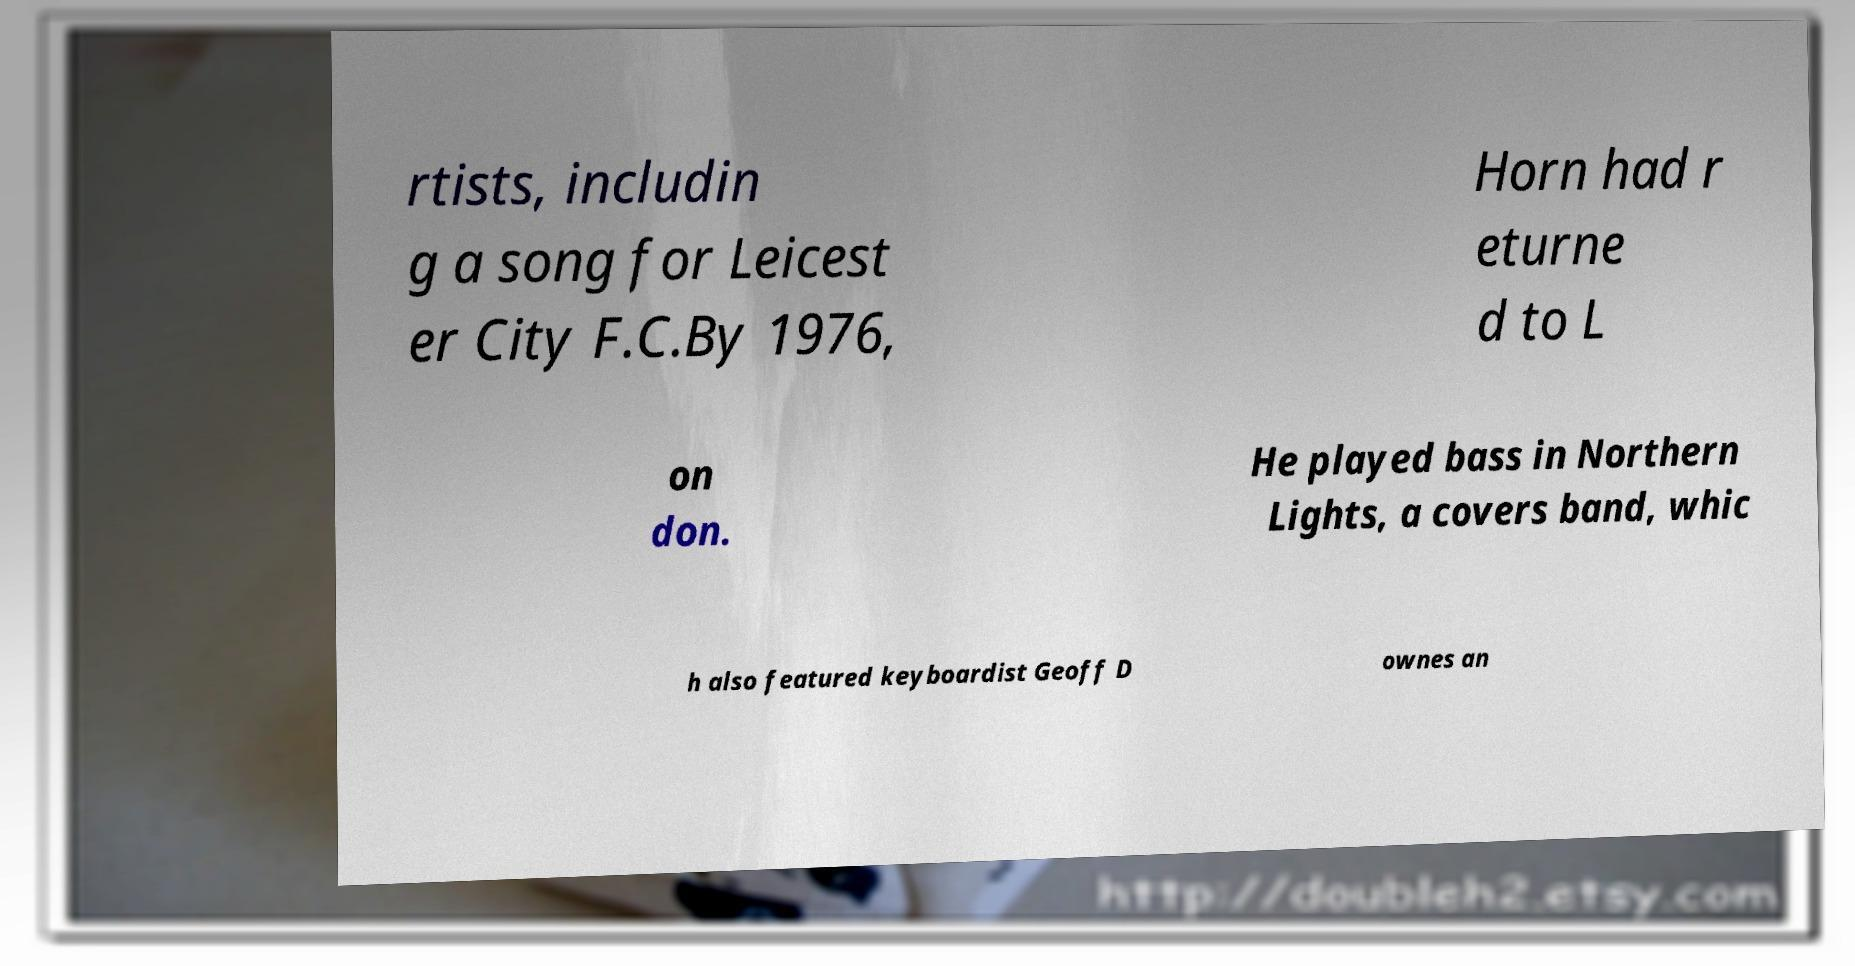For documentation purposes, I need the text within this image transcribed. Could you provide that? rtists, includin g a song for Leicest er City F.C.By 1976, Horn had r eturne d to L on don. He played bass in Northern Lights, a covers band, whic h also featured keyboardist Geoff D ownes an 